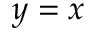Convert formula to latex. <formula><loc_0><loc_0><loc_500><loc_500>y = x</formula> 